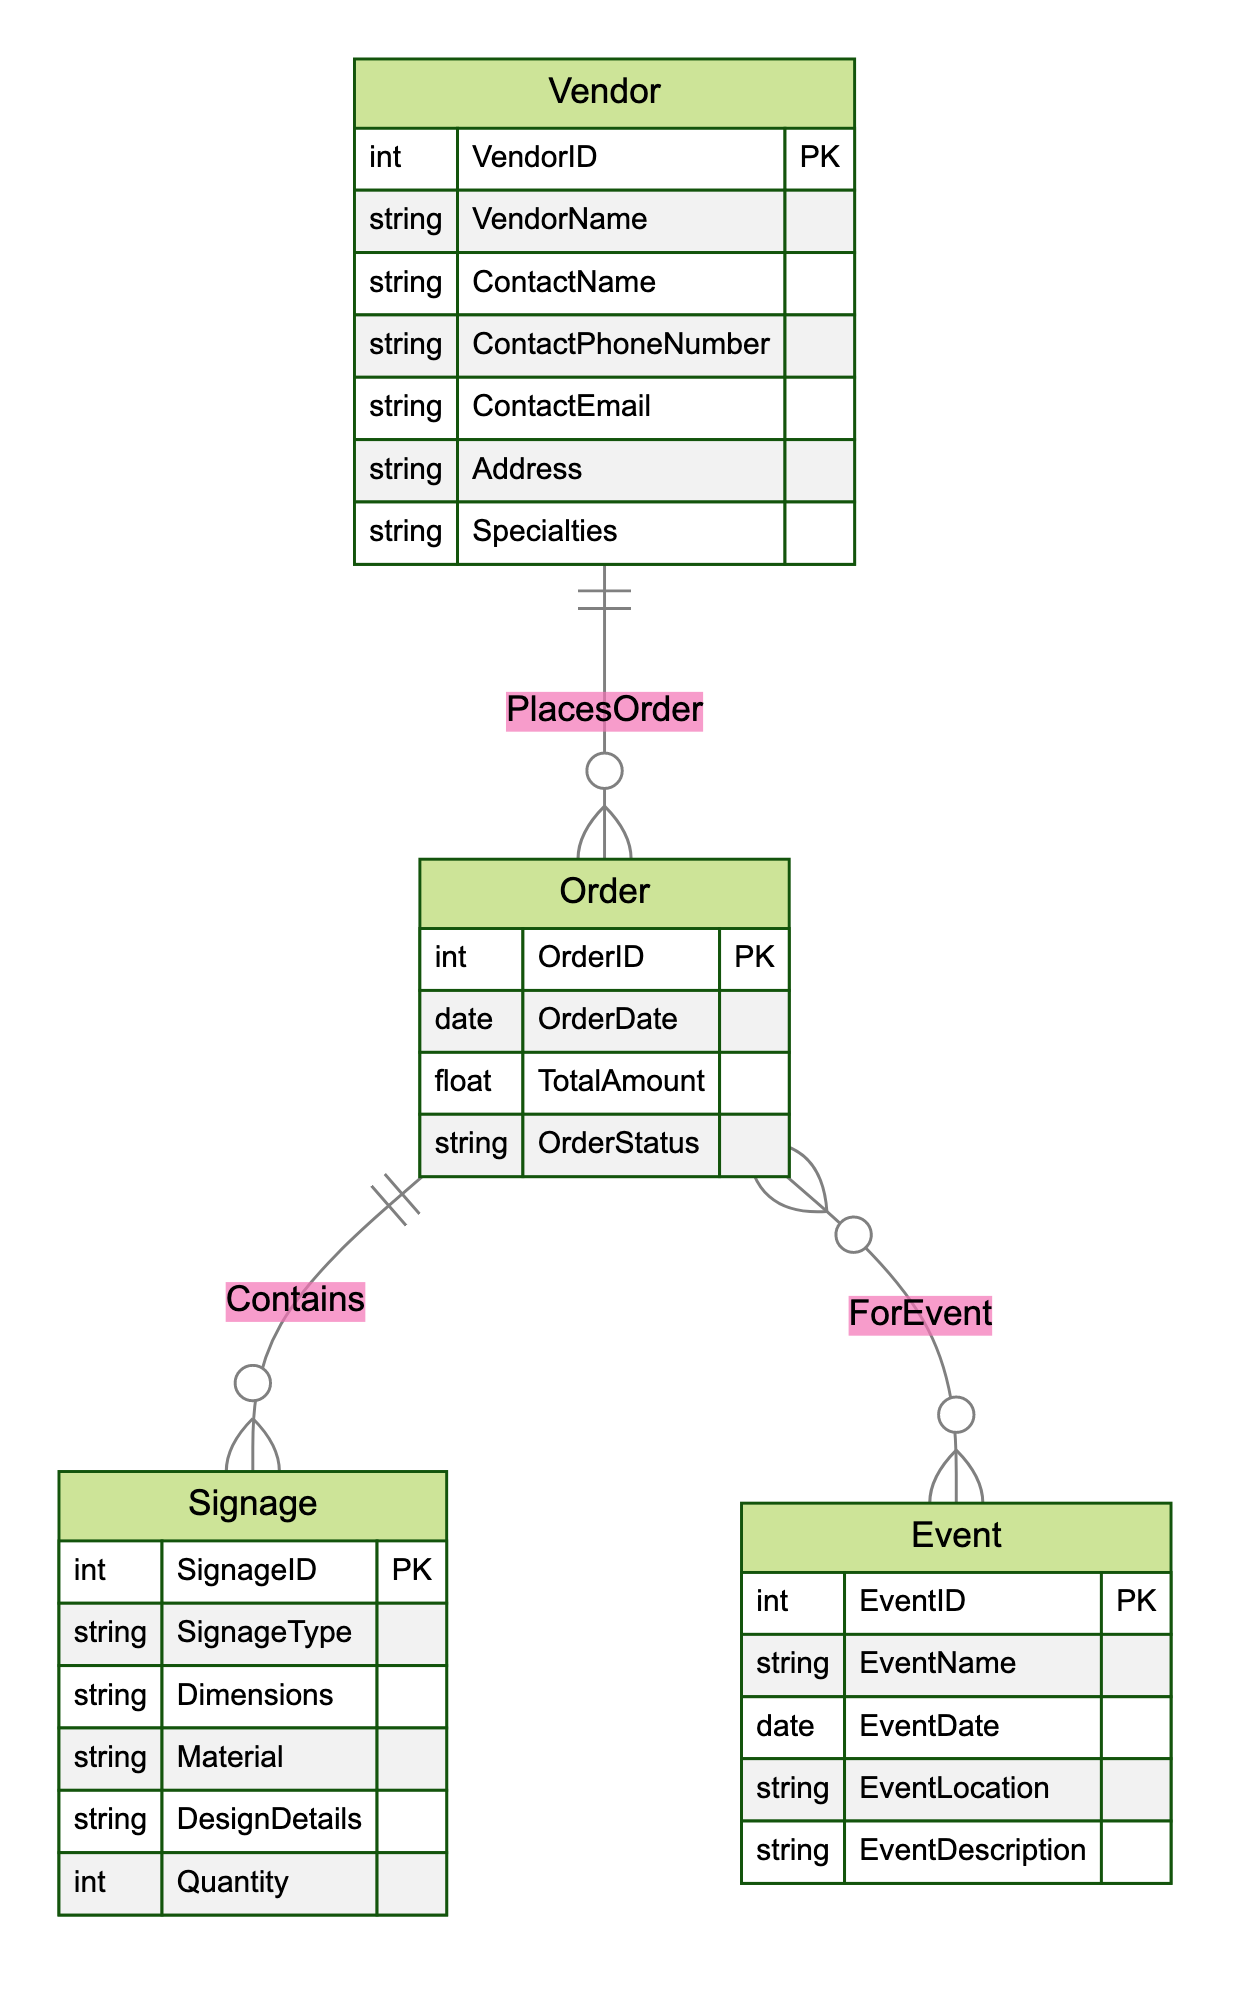What is the primary key for the Vendor entity? The primary key for the Vendor entity is VendorID, which uniquely identifies each vendor in the system. We can see that it is marked with PK in the entity section of the diagram.
Answer: VendorID How many attributes does the Order entity have? The Order entity consists of four attributes: OrderID, OrderDate, TotalAmount, and OrderStatus. By counting the listed attributes under the Order entity in the diagram, we reach the total.
Answer: 4 What relationship connects the Vendor and Order entities? The relationship that connects the Vendor and Order entities is named PlacesOrder. This is indicated by the connecting line with the label between these two entities in the diagram.
Answer: PlacesOrder How many entities are associated with the Signage entity according to the diagram? According to the diagram, the Signage entity is connected to the Order entity via the Contains relationship. Since the Signage only relates to Orders and no other entities, we count one association.
Answer: 1 What cardinality does the Orders relationship have with the Events? The cardinality for the Orders relationship with the Events is N:M, which indicates that multiple orders can be connected to multiple events. This cardinality is noted at the connecting line between Order and Event.
Answer: N:M Which entity consists of the attribute ContactEmail? The entity that includes the attribute ContactEmail is the Vendor. We can determine this by looking at the attributes listed under the Vendor in the diagram.
Answer: Vendor How many types of signage are linked to an order? An order can contain multiple types of signage since the Contains relationship indicates a one-to-many relationship from Order to Signage. Thus, an order can link to several signage types.
Answer: Many What attribute is used to designate the order's status? The attribute used to designate the order's status is OrderStatus. This is directly indicated in the attributes of the Order entity in the diagram.
Answer: OrderStatus What is the relationship type between the Order and Signage entities? The relationship type between the Order and Signage entities is Contains. This is evident in how these two entities are linked in the diagram with the specified relationship label.
Answer: Contains 